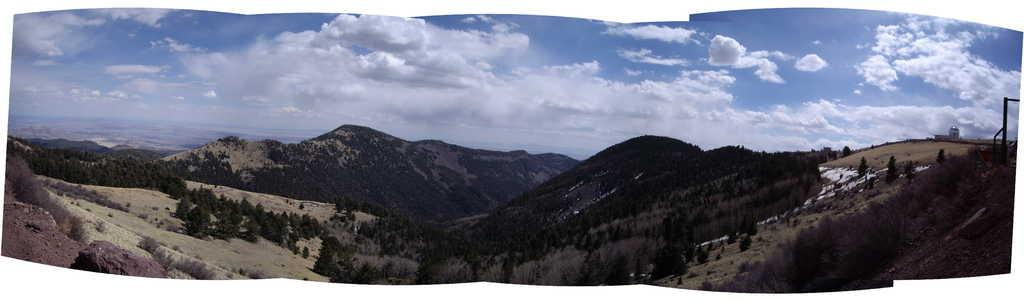What type of natural formation can be seen in the image? There are mountains in the image. What vegetation is present on the mountains? Trees are present on the mountains. What is visible at the top of the image? The sky is visible at the top of the image. What can be seen in the sky? Clouds are present in the sky. What type of vase can be seen in the aftermath of the cable incident in the image? There is no vase, aftermath, or cable incident present in the image. 